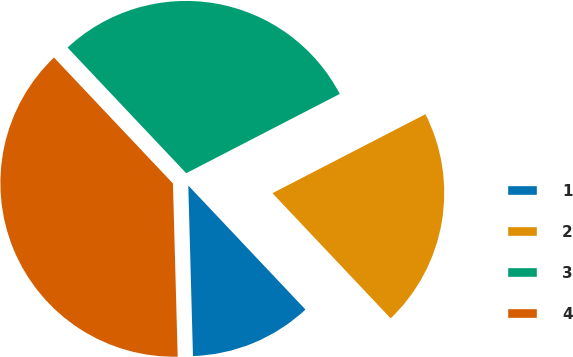Convert chart. <chart><loc_0><loc_0><loc_500><loc_500><pie_chart><fcel>1<fcel>2<fcel>3<fcel>4<nl><fcel>11.61%<fcel>20.54%<fcel>29.46%<fcel>38.39%<nl></chart> 